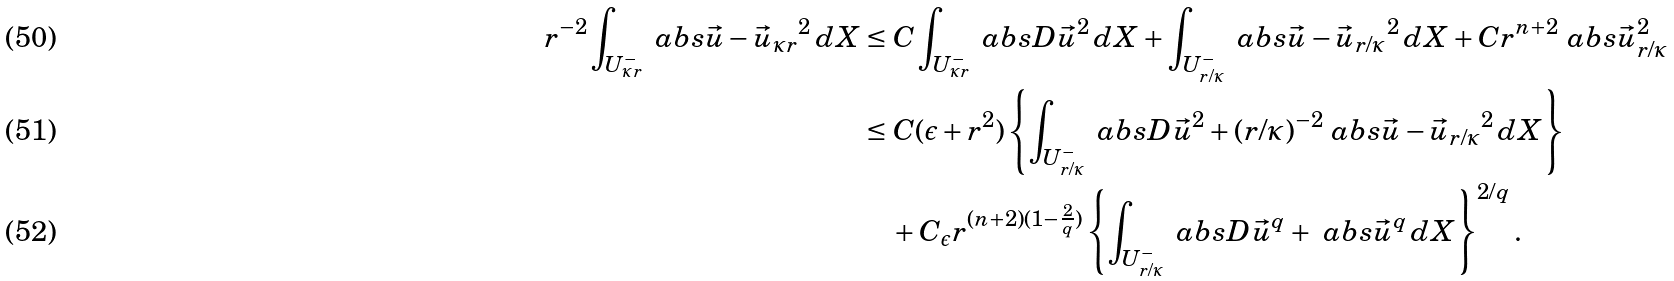<formula> <loc_0><loc_0><loc_500><loc_500>r ^ { - 2 } \int _ { U ^ { - } _ { \kappa r } } \ a b s { \vec { u } - \vec { u } _ { \kappa r } } ^ { 2 } \, d X & \leq C \int _ { U ^ { - } _ { \kappa r } } \ a b s { D \vec { u } } ^ { 2 } \, d X + \int _ { U ^ { - } _ { r / \kappa } } \ a b s { \vec { u } - \vec { u } _ { r / \kappa } } ^ { 2 } \, d X + C r ^ { n + 2 } \ a b s { \vec { u } _ { r / \kappa } } ^ { 2 } \\ & \leq C ( \epsilon + r ^ { 2 } ) \left \{ \int _ { U ^ { - } _ { r / \kappa } } \ a b s { D \vec { u } } ^ { 2 } + ( r / \kappa ) ^ { - 2 } \ a b s { \vec { u } - \vec { u } _ { r / \kappa } } ^ { 2 } \, d X \right \} \\ & \quad + C _ { \epsilon } r ^ { ( n + 2 ) ( 1 - \frac { 2 } { q } ) } \left \{ \int _ { U ^ { - } _ { r / \kappa } } \ a b s { D \vec { u } } ^ { q } + \ a b s { \vec { u } } ^ { q } \, d X \right \} ^ { 2 / q } .</formula> 